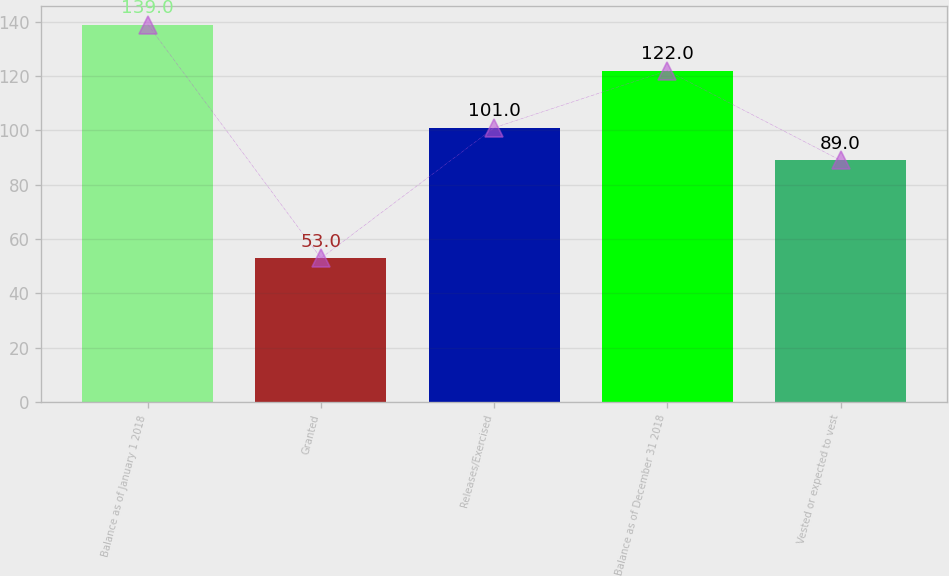<chart> <loc_0><loc_0><loc_500><loc_500><bar_chart><fcel>Balance as of January 1 2018<fcel>Granted<fcel>Releases/Exercised<fcel>Balance as of December 31 2018<fcel>Vested or expected to vest<nl><fcel>139<fcel>53<fcel>101<fcel>122<fcel>89<nl></chart> 